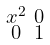Convert formula to latex. <formula><loc_0><loc_0><loc_500><loc_500>\begin{smallmatrix} x ^ { 2 } & 0 \\ 0 & 1 \end{smallmatrix}</formula> 